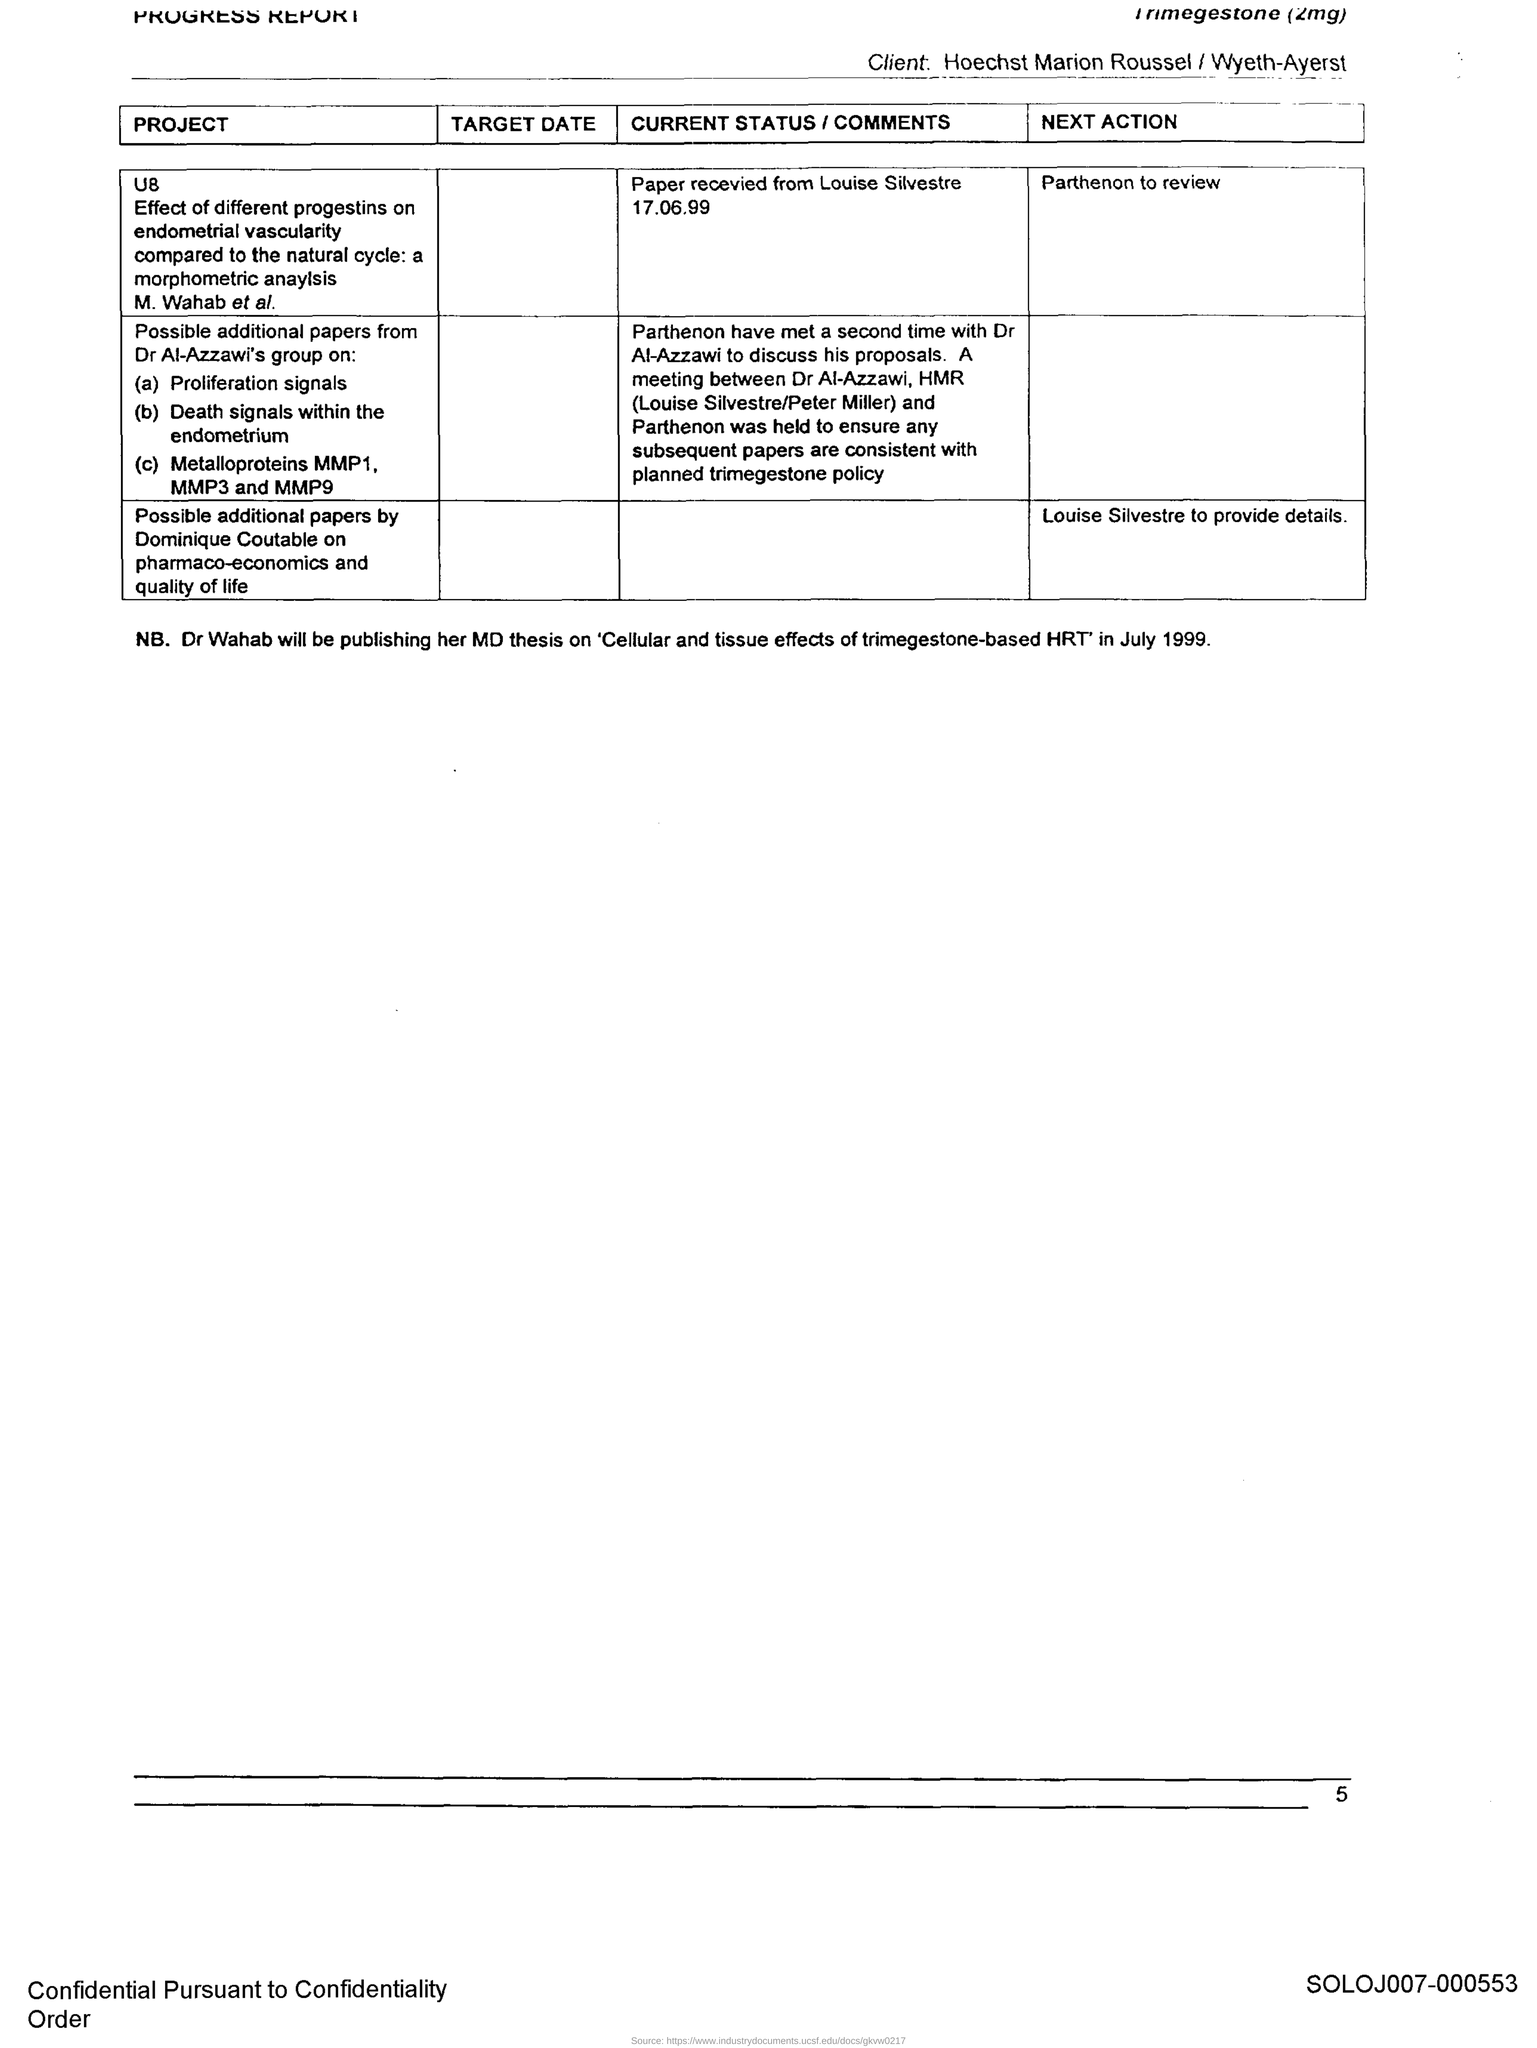Who will be publishing the MD thesis on "Cellular and tissue effects of trimegestone-based HRT" in July 1999?
Offer a terse response. Dr Wahab. 